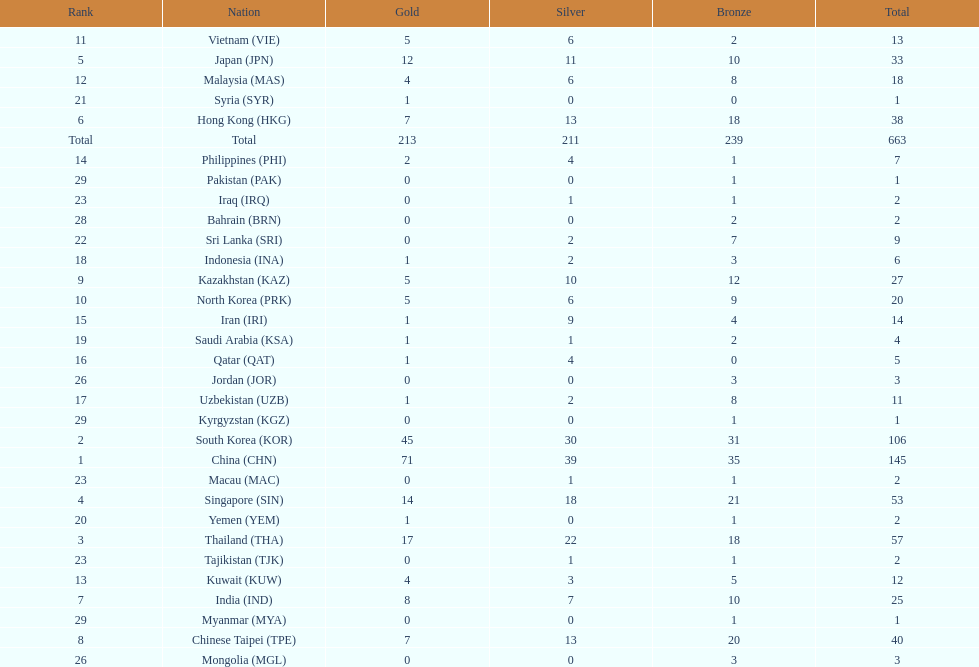What is the difference between the total amount of medals won by qatar and indonesia? 1. 